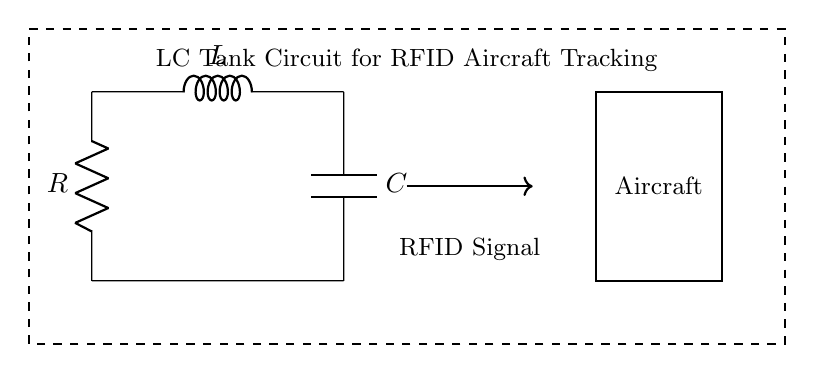What are the components in this LC tank circuit? The components illustrated in the diagram are a resistor, an inductor, and a capacitor, which are standard elements in an LC tank circuit. Their representation includes labeled symbols indicating their types.
Answer: Resistor, Inductor, Capacitor What is the primary function of the LC tank circuit in this context? The LC tank circuit is utilized for resonating at a specific frequency for RFID applications, which enables efficient detection and tracking of aircraft signals. In RFID systems, resonant circuits help in modulating and demodulating signals.
Answer: RFID signal detection How does the inductor affect the circuit's frequency response? The inductor's presence in the circuit introduces inductive reactance, which varies with frequency and is essential for tuning the circuit to resonate at a desired frequency, affecting overall impedance and performance.
Answer: It tunes frequency response What is the relationship between the resistor, inductor, and capacitor for resonance frequency? The resonance frequency of the LC circuit is determined by the values of the inductor and capacitor using the formula f_0 equals one over two pi times the square root of LC, where L is inductance and C is capacitance. The resistor influences damping but not the primal resonance.
Answer: f_0 = 1 / (2π√(LC)) Which component is responsible for damping in this circuit? The resistor is the component that introduces damping by dissipating energy, which affects the quality factor of the circuit and can lead to reduced oscillation amplitude over time.
Answer: Resistor 